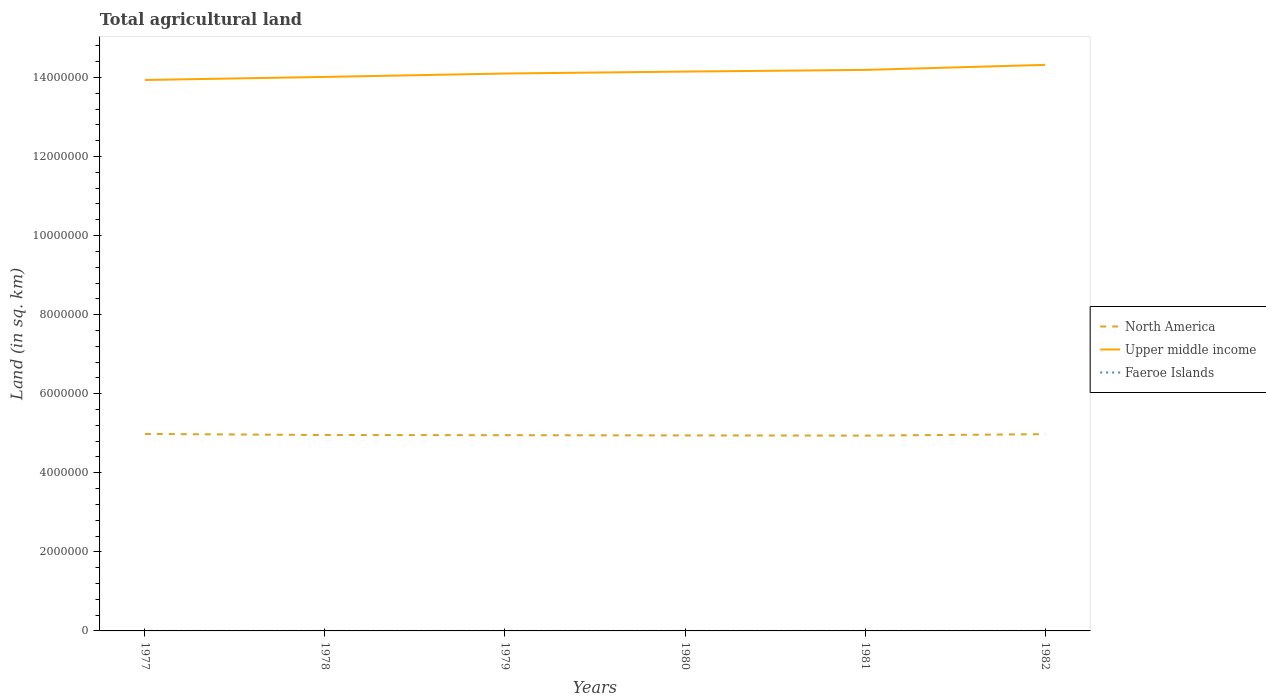Is the number of lines equal to the number of legend labels?
Offer a very short reply. Yes. Across all years, what is the maximum total agricultural land in Upper middle income?
Give a very brief answer. 1.39e+07. In which year was the total agricultural land in Upper middle income maximum?
Ensure brevity in your answer.  1977. What is the total total agricultural land in Upper middle income in the graph?
Provide a succinct answer. -9.14e+04. Is the total agricultural land in North America strictly greater than the total agricultural land in Upper middle income over the years?
Your response must be concise. Yes. How many lines are there?
Give a very brief answer. 3. How many legend labels are there?
Make the answer very short. 3. What is the title of the graph?
Your answer should be very brief. Total agricultural land. What is the label or title of the X-axis?
Make the answer very short. Years. What is the label or title of the Y-axis?
Ensure brevity in your answer.  Land (in sq. km). What is the Land (in sq. km) of North America in 1977?
Provide a succinct answer. 4.98e+06. What is the Land (in sq. km) in Upper middle income in 1977?
Offer a very short reply. 1.39e+07. What is the Land (in sq. km) in Faeroe Islands in 1977?
Your response must be concise. 30. What is the Land (in sq. km) in North America in 1978?
Provide a short and direct response. 4.96e+06. What is the Land (in sq. km) in Upper middle income in 1978?
Offer a very short reply. 1.40e+07. What is the Land (in sq. km) of North America in 1979?
Make the answer very short. 4.95e+06. What is the Land (in sq. km) of Upper middle income in 1979?
Provide a short and direct response. 1.41e+07. What is the Land (in sq. km) of North America in 1980?
Offer a terse response. 4.95e+06. What is the Land (in sq. km) of Upper middle income in 1980?
Offer a very short reply. 1.41e+07. What is the Land (in sq. km) of Faeroe Islands in 1980?
Your answer should be compact. 30. What is the Land (in sq. km) of North America in 1981?
Make the answer very short. 4.94e+06. What is the Land (in sq. km) of Upper middle income in 1981?
Your answer should be very brief. 1.42e+07. What is the Land (in sq. km) in Faeroe Islands in 1981?
Keep it short and to the point. 30. What is the Land (in sq. km) in North America in 1982?
Your response must be concise. 4.98e+06. What is the Land (in sq. km) in Upper middle income in 1982?
Your response must be concise. 1.43e+07. Across all years, what is the maximum Land (in sq. km) of North America?
Provide a succinct answer. 4.98e+06. Across all years, what is the maximum Land (in sq. km) of Upper middle income?
Make the answer very short. 1.43e+07. Across all years, what is the maximum Land (in sq. km) of Faeroe Islands?
Your response must be concise. 30. Across all years, what is the minimum Land (in sq. km) of North America?
Ensure brevity in your answer.  4.94e+06. Across all years, what is the minimum Land (in sq. km) in Upper middle income?
Provide a short and direct response. 1.39e+07. Across all years, what is the minimum Land (in sq. km) in Faeroe Islands?
Your answer should be compact. 30. What is the total Land (in sq. km) in North America in the graph?
Provide a short and direct response. 2.98e+07. What is the total Land (in sq. km) of Upper middle income in the graph?
Offer a terse response. 8.47e+07. What is the total Land (in sq. km) of Faeroe Islands in the graph?
Your response must be concise. 180. What is the difference between the Land (in sq. km) of North America in 1977 and that in 1978?
Provide a short and direct response. 2.68e+04. What is the difference between the Land (in sq. km) of Upper middle income in 1977 and that in 1978?
Offer a terse response. -7.75e+04. What is the difference between the Land (in sq. km) of Faeroe Islands in 1977 and that in 1978?
Make the answer very short. 0. What is the difference between the Land (in sq. km) in North America in 1977 and that in 1979?
Ensure brevity in your answer.  3.18e+04. What is the difference between the Land (in sq. km) in Upper middle income in 1977 and that in 1979?
Offer a terse response. -1.64e+05. What is the difference between the Land (in sq. km) of Faeroe Islands in 1977 and that in 1979?
Keep it short and to the point. 0. What is the difference between the Land (in sq. km) in North America in 1977 and that in 1980?
Offer a very short reply. 3.69e+04. What is the difference between the Land (in sq. km) of Upper middle income in 1977 and that in 1980?
Your answer should be compact. -2.13e+05. What is the difference between the Land (in sq. km) in Faeroe Islands in 1977 and that in 1980?
Make the answer very short. 0. What is the difference between the Land (in sq. km) in North America in 1977 and that in 1981?
Ensure brevity in your answer.  4.20e+04. What is the difference between the Land (in sq. km) in Upper middle income in 1977 and that in 1981?
Make the answer very short. -2.55e+05. What is the difference between the Land (in sq. km) of North America in 1977 and that in 1982?
Your answer should be very brief. 5740. What is the difference between the Land (in sq. km) in Upper middle income in 1977 and that in 1982?
Ensure brevity in your answer.  -3.82e+05. What is the difference between the Land (in sq. km) of Faeroe Islands in 1977 and that in 1982?
Give a very brief answer. 0. What is the difference between the Land (in sq. km) in North America in 1978 and that in 1979?
Provide a short and direct response. 5080. What is the difference between the Land (in sq. km) of Upper middle income in 1978 and that in 1979?
Your answer should be very brief. -8.62e+04. What is the difference between the Land (in sq. km) of North America in 1978 and that in 1980?
Your answer should be compact. 1.02e+04. What is the difference between the Land (in sq. km) in Upper middle income in 1978 and that in 1980?
Provide a short and direct response. -1.35e+05. What is the difference between the Land (in sq. km) in Faeroe Islands in 1978 and that in 1980?
Keep it short and to the point. 0. What is the difference between the Land (in sq. km) in North America in 1978 and that in 1981?
Your answer should be very brief. 1.52e+04. What is the difference between the Land (in sq. km) of Upper middle income in 1978 and that in 1981?
Offer a terse response. -1.78e+05. What is the difference between the Land (in sq. km) of Faeroe Islands in 1978 and that in 1981?
Make the answer very short. 0. What is the difference between the Land (in sq. km) of North America in 1978 and that in 1982?
Give a very brief answer. -2.10e+04. What is the difference between the Land (in sq. km) of Upper middle income in 1978 and that in 1982?
Give a very brief answer. -3.05e+05. What is the difference between the Land (in sq. km) of North America in 1979 and that in 1980?
Offer a very short reply. 5070. What is the difference between the Land (in sq. km) of Upper middle income in 1979 and that in 1980?
Provide a short and direct response. -4.90e+04. What is the difference between the Land (in sq. km) of North America in 1979 and that in 1981?
Give a very brief answer. 1.01e+04. What is the difference between the Land (in sq. km) of Upper middle income in 1979 and that in 1981?
Ensure brevity in your answer.  -9.14e+04. What is the difference between the Land (in sq. km) in Faeroe Islands in 1979 and that in 1981?
Provide a succinct answer. 0. What is the difference between the Land (in sq. km) of North America in 1979 and that in 1982?
Offer a terse response. -2.61e+04. What is the difference between the Land (in sq. km) of Upper middle income in 1979 and that in 1982?
Provide a short and direct response. -2.19e+05. What is the difference between the Land (in sq. km) of Faeroe Islands in 1979 and that in 1982?
Your response must be concise. 0. What is the difference between the Land (in sq. km) of North America in 1980 and that in 1981?
Your answer should be very brief. 5070. What is the difference between the Land (in sq. km) of Upper middle income in 1980 and that in 1981?
Provide a succinct answer. -4.24e+04. What is the difference between the Land (in sq. km) in North America in 1980 and that in 1982?
Your answer should be very brief. -3.12e+04. What is the difference between the Land (in sq. km) of Upper middle income in 1980 and that in 1982?
Your answer should be compact. -1.70e+05. What is the difference between the Land (in sq. km) in Faeroe Islands in 1980 and that in 1982?
Offer a terse response. 0. What is the difference between the Land (in sq. km) in North America in 1981 and that in 1982?
Your answer should be very brief. -3.62e+04. What is the difference between the Land (in sq. km) of Upper middle income in 1981 and that in 1982?
Your response must be concise. -1.27e+05. What is the difference between the Land (in sq. km) of Faeroe Islands in 1981 and that in 1982?
Give a very brief answer. 0. What is the difference between the Land (in sq. km) of North America in 1977 and the Land (in sq. km) of Upper middle income in 1978?
Give a very brief answer. -9.03e+06. What is the difference between the Land (in sq. km) in North America in 1977 and the Land (in sq. km) in Faeroe Islands in 1978?
Give a very brief answer. 4.98e+06. What is the difference between the Land (in sq. km) in Upper middle income in 1977 and the Land (in sq. km) in Faeroe Islands in 1978?
Your response must be concise. 1.39e+07. What is the difference between the Land (in sq. km) of North America in 1977 and the Land (in sq. km) of Upper middle income in 1979?
Provide a succinct answer. -9.12e+06. What is the difference between the Land (in sq. km) in North America in 1977 and the Land (in sq. km) in Faeroe Islands in 1979?
Your answer should be very brief. 4.98e+06. What is the difference between the Land (in sq. km) of Upper middle income in 1977 and the Land (in sq. km) of Faeroe Islands in 1979?
Keep it short and to the point. 1.39e+07. What is the difference between the Land (in sq. km) of North America in 1977 and the Land (in sq. km) of Upper middle income in 1980?
Keep it short and to the point. -9.17e+06. What is the difference between the Land (in sq. km) in North America in 1977 and the Land (in sq. km) in Faeroe Islands in 1980?
Offer a very short reply. 4.98e+06. What is the difference between the Land (in sq. km) of Upper middle income in 1977 and the Land (in sq. km) of Faeroe Islands in 1980?
Ensure brevity in your answer.  1.39e+07. What is the difference between the Land (in sq. km) of North America in 1977 and the Land (in sq. km) of Upper middle income in 1981?
Provide a succinct answer. -9.21e+06. What is the difference between the Land (in sq. km) of North America in 1977 and the Land (in sq. km) of Faeroe Islands in 1981?
Make the answer very short. 4.98e+06. What is the difference between the Land (in sq. km) in Upper middle income in 1977 and the Land (in sq. km) in Faeroe Islands in 1981?
Offer a very short reply. 1.39e+07. What is the difference between the Land (in sq. km) of North America in 1977 and the Land (in sq. km) of Upper middle income in 1982?
Offer a terse response. -9.34e+06. What is the difference between the Land (in sq. km) in North America in 1977 and the Land (in sq. km) in Faeroe Islands in 1982?
Your answer should be very brief. 4.98e+06. What is the difference between the Land (in sq. km) in Upper middle income in 1977 and the Land (in sq. km) in Faeroe Islands in 1982?
Keep it short and to the point. 1.39e+07. What is the difference between the Land (in sq. km) of North America in 1978 and the Land (in sq. km) of Upper middle income in 1979?
Keep it short and to the point. -9.14e+06. What is the difference between the Land (in sq. km) in North America in 1978 and the Land (in sq. km) in Faeroe Islands in 1979?
Your answer should be compact. 4.96e+06. What is the difference between the Land (in sq. km) in Upper middle income in 1978 and the Land (in sq. km) in Faeroe Islands in 1979?
Provide a succinct answer. 1.40e+07. What is the difference between the Land (in sq. km) in North America in 1978 and the Land (in sq. km) in Upper middle income in 1980?
Give a very brief answer. -9.19e+06. What is the difference between the Land (in sq. km) in North America in 1978 and the Land (in sq. km) in Faeroe Islands in 1980?
Your response must be concise. 4.96e+06. What is the difference between the Land (in sq. km) in Upper middle income in 1978 and the Land (in sq. km) in Faeroe Islands in 1980?
Your response must be concise. 1.40e+07. What is the difference between the Land (in sq. km) of North America in 1978 and the Land (in sq. km) of Upper middle income in 1981?
Give a very brief answer. -9.24e+06. What is the difference between the Land (in sq. km) of North America in 1978 and the Land (in sq. km) of Faeroe Islands in 1981?
Keep it short and to the point. 4.96e+06. What is the difference between the Land (in sq. km) of Upper middle income in 1978 and the Land (in sq. km) of Faeroe Islands in 1981?
Ensure brevity in your answer.  1.40e+07. What is the difference between the Land (in sq. km) in North America in 1978 and the Land (in sq. km) in Upper middle income in 1982?
Your answer should be very brief. -9.36e+06. What is the difference between the Land (in sq. km) of North America in 1978 and the Land (in sq. km) of Faeroe Islands in 1982?
Your response must be concise. 4.96e+06. What is the difference between the Land (in sq. km) in Upper middle income in 1978 and the Land (in sq. km) in Faeroe Islands in 1982?
Offer a terse response. 1.40e+07. What is the difference between the Land (in sq. km) in North America in 1979 and the Land (in sq. km) in Upper middle income in 1980?
Your answer should be compact. -9.20e+06. What is the difference between the Land (in sq. km) of North America in 1979 and the Land (in sq. km) of Faeroe Islands in 1980?
Keep it short and to the point. 4.95e+06. What is the difference between the Land (in sq. km) of Upper middle income in 1979 and the Land (in sq. km) of Faeroe Islands in 1980?
Give a very brief answer. 1.41e+07. What is the difference between the Land (in sq. km) of North America in 1979 and the Land (in sq. km) of Upper middle income in 1981?
Ensure brevity in your answer.  -9.24e+06. What is the difference between the Land (in sq. km) of North America in 1979 and the Land (in sq. km) of Faeroe Islands in 1981?
Make the answer very short. 4.95e+06. What is the difference between the Land (in sq. km) of Upper middle income in 1979 and the Land (in sq. km) of Faeroe Islands in 1981?
Ensure brevity in your answer.  1.41e+07. What is the difference between the Land (in sq. km) of North America in 1979 and the Land (in sq. km) of Upper middle income in 1982?
Your answer should be compact. -9.37e+06. What is the difference between the Land (in sq. km) of North America in 1979 and the Land (in sq. km) of Faeroe Islands in 1982?
Make the answer very short. 4.95e+06. What is the difference between the Land (in sq. km) of Upper middle income in 1979 and the Land (in sq. km) of Faeroe Islands in 1982?
Offer a terse response. 1.41e+07. What is the difference between the Land (in sq. km) of North America in 1980 and the Land (in sq. km) of Upper middle income in 1981?
Make the answer very short. -9.25e+06. What is the difference between the Land (in sq. km) of North America in 1980 and the Land (in sq. km) of Faeroe Islands in 1981?
Keep it short and to the point. 4.95e+06. What is the difference between the Land (in sq. km) in Upper middle income in 1980 and the Land (in sq. km) in Faeroe Islands in 1981?
Provide a succinct answer. 1.41e+07. What is the difference between the Land (in sq. km) of North America in 1980 and the Land (in sq. km) of Upper middle income in 1982?
Your answer should be very brief. -9.37e+06. What is the difference between the Land (in sq. km) in North America in 1980 and the Land (in sq. km) in Faeroe Islands in 1982?
Give a very brief answer. 4.95e+06. What is the difference between the Land (in sq. km) in Upper middle income in 1980 and the Land (in sq. km) in Faeroe Islands in 1982?
Your response must be concise. 1.41e+07. What is the difference between the Land (in sq. km) in North America in 1981 and the Land (in sq. km) in Upper middle income in 1982?
Your answer should be very brief. -9.38e+06. What is the difference between the Land (in sq. km) in North America in 1981 and the Land (in sq. km) in Faeroe Islands in 1982?
Offer a terse response. 4.94e+06. What is the difference between the Land (in sq. km) in Upper middle income in 1981 and the Land (in sq. km) in Faeroe Islands in 1982?
Provide a short and direct response. 1.42e+07. What is the average Land (in sq. km) in North America per year?
Give a very brief answer. 4.96e+06. What is the average Land (in sq. km) of Upper middle income per year?
Keep it short and to the point. 1.41e+07. In the year 1977, what is the difference between the Land (in sq. km) in North America and Land (in sq. km) in Upper middle income?
Ensure brevity in your answer.  -8.95e+06. In the year 1977, what is the difference between the Land (in sq. km) of North America and Land (in sq. km) of Faeroe Islands?
Keep it short and to the point. 4.98e+06. In the year 1977, what is the difference between the Land (in sq. km) of Upper middle income and Land (in sq. km) of Faeroe Islands?
Make the answer very short. 1.39e+07. In the year 1978, what is the difference between the Land (in sq. km) of North America and Land (in sq. km) of Upper middle income?
Your response must be concise. -9.06e+06. In the year 1978, what is the difference between the Land (in sq. km) in North America and Land (in sq. km) in Faeroe Islands?
Your answer should be very brief. 4.96e+06. In the year 1978, what is the difference between the Land (in sq. km) in Upper middle income and Land (in sq. km) in Faeroe Islands?
Offer a terse response. 1.40e+07. In the year 1979, what is the difference between the Land (in sq. km) of North America and Land (in sq. km) of Upper middle income?
Offer a very short reply. -9.15e+06. In the year 1979, what is the difference between the Land (in sq. km) in North America and Land (in sq. km) in Faeroe Islands?
Keep it short and to the point. 4.95e+06. In the year 1979, what is the difference between the Land (in sq. km) of Upper middle income and Land (in sq. km) of Faeroe Islands?
Keep it short and to the point. 1.41e+07. In the year 1980, what is the difference between the Land (in sq. km) of North America and Land (in sq. km) of Upper middle income?
Give a very brief answer. -9.20e+06. In the year 1980, what is the difference between the Land (in sq. km) in North America and Land (in sq. km) in Faeroe Islands?
Provide a succinct answer. 4.95e+06. In the year 1980, what is the difference between the Land (in sq. km) in Upper middle income and Land (in sq. km) in Faeroe Islands?
Give a very brief answer. 1.41e+07. In the year 1981, what is the difference between the Land (in sq. km) in North America and Land (in sq. km) in Upper middle income?
Provide a succinct answer. -9.25e+06. In the year 1981, what is the difference between the Land (in sq. km) of North America and Land (in sq. km) of Faeroe Islands?
Offer a very short reply. 4.94e+06. In the year 1981, what is the difference between the Land (in sq. km) in Upper middle income and Land (in sq. km) in Faeroe Islands?
Ensure brevity in your answer.  1.42e+07. In the year 1982, what is the difference between the Land (in sq. km) in North America and Land (in sq. km) in Upper middle income?
Your answer should be compact. -9.34e+06. In the year 1982, what is the difference between the Land (in sq. km) of North America and Land (in sq. km) of Faeroe Islands?
Offer a terse response. 4.98e+06. In the year 1982, what is the difference between the Land (in sq. km) in Upper middle income and Land (in sq. km) in Faeroe Islands?
Give a very brief answer. 1.43e+07. What is the ratio of the Land (in sq. km) in North America in 1977 to that in 1978?
Provide a short and direct response. 1.01. What is the ratio of the Land (in sq. km) in North America in 1977 to that in 1979?
Your response must be concise. 1.01. What is the ratio of the Land (in sq. km) in Upper middle income in 1977 to that in 1979?
Make the answer very short. 0.99. What is the ratio of the Land (in sq. km) of North America in 1977 to that in 1980?
Make the answer very short. 1.01. What is the ratio of the Land (in sq. km) of North America in 1977 to that in 1981?
Make the answer very short. 1.01. What is the ratio of the Land (in sq. km) of Upper middle income in 1977 to that in 1981?
Give a very brief answer. 0.98. What is the ratio of the Land (in sq. km) of Upper middle income in 1977 to that in 1982?
Ensure brevity in your answer.  0.97. What is the ratio of the Land (in sq. km) of North America in 1978 to that in 1979?
Provide a short and direct response. 1. What is the ratio of the Land (in sq. km) of Upper middle income in 1978 to that in 1979?
Provide a succinct answer. 0.99. What is the ratio of the Land (in sq. km) in Faeroe Islands in 1978 to that in 1980?
Your answer should be compact. 1. What is the ratio of the Land (in sq. km) of North America in 1978 to that in 1981?
Offer a terse response. 1. What is the ratio of the Land (in sq. km) in Upper middle income in 1978 to that in 1981?
Give a very brief answer. 0.99. What is the ratio of the Land (in sq. km) of Faeroe Islands in 1978 to that in 1981?
Give a very brief answer. 1. What is the ratio of the Land (in sq. km) in North America in 1978 to that in 1982?
Your answer should be compact. 1. What is the ratio of the Land (in sq. km) in Upper middle income in 1978 to that in 1982?
Keep it short and to the point. 0.98. What is the ratio of the Land (in sq. km) of North America in 1979 to that in 1980?
Ensure brevity in your answer.  1. What is the ratio of the Land (in sq. km) of Upper middle income in 1979 to that in 1981?
Make the answer very short. 0.99. What is the ratio of the Land (in sq. km) of North America in 1979 to that in 1982?
Your response must be concise. 0.99. What is the ratio of the Land (in sq. km) of Upper middle income in 1979 to that in 1982?
Your answer should be compact. 0.98. What is the ratio of the Land (in sq. km) in Faeroe Islands in 1979 to that in 1982?
Your response must be concise. 1. What is the ratio of the Land (in sq. km) of North America in 1980 to that in 1981?
Offer a terse response. 1. What is the ratio of the Land (in sq. km) in Faeroe Islands in 1980 to that in 1981?
Offer a terse response. 1. What is the ratio of the Land (in sq. km) of Upper middle income in 1980 to that in 1982?
Make the answer very short. 0.99. What is the ratio of the Land (in sq. km) of Faeroe Islands in 1981 to that in 1982?
Provide a succinct answer. 1. What is the difference between the highest and the second highest Land (in sq. km) in North America?
Make the answer very short. 5740. What is the difference between the highest and the second highest Land (in sq. km) in Upper middle income?
Ensure brevity in your answer.  1.27e+05. What is the difference between the highest and the second highest Land (in sq. km) of Faeroe Islands?
Provide a short and direct response. 0. What is the difference between the highest and the lowest Land (in sq. km) of North America?
Offer a terse response. 4.20e+04. What is the difference between the highest and the lowest Land (in sq. km) of Upper middle income?
Keep it short and to the point. 3.82e+05. What is the difference between the highest and the lowest Land (in sq. km) in Faeroe Islands?
Provide a short and direct response. 0. 